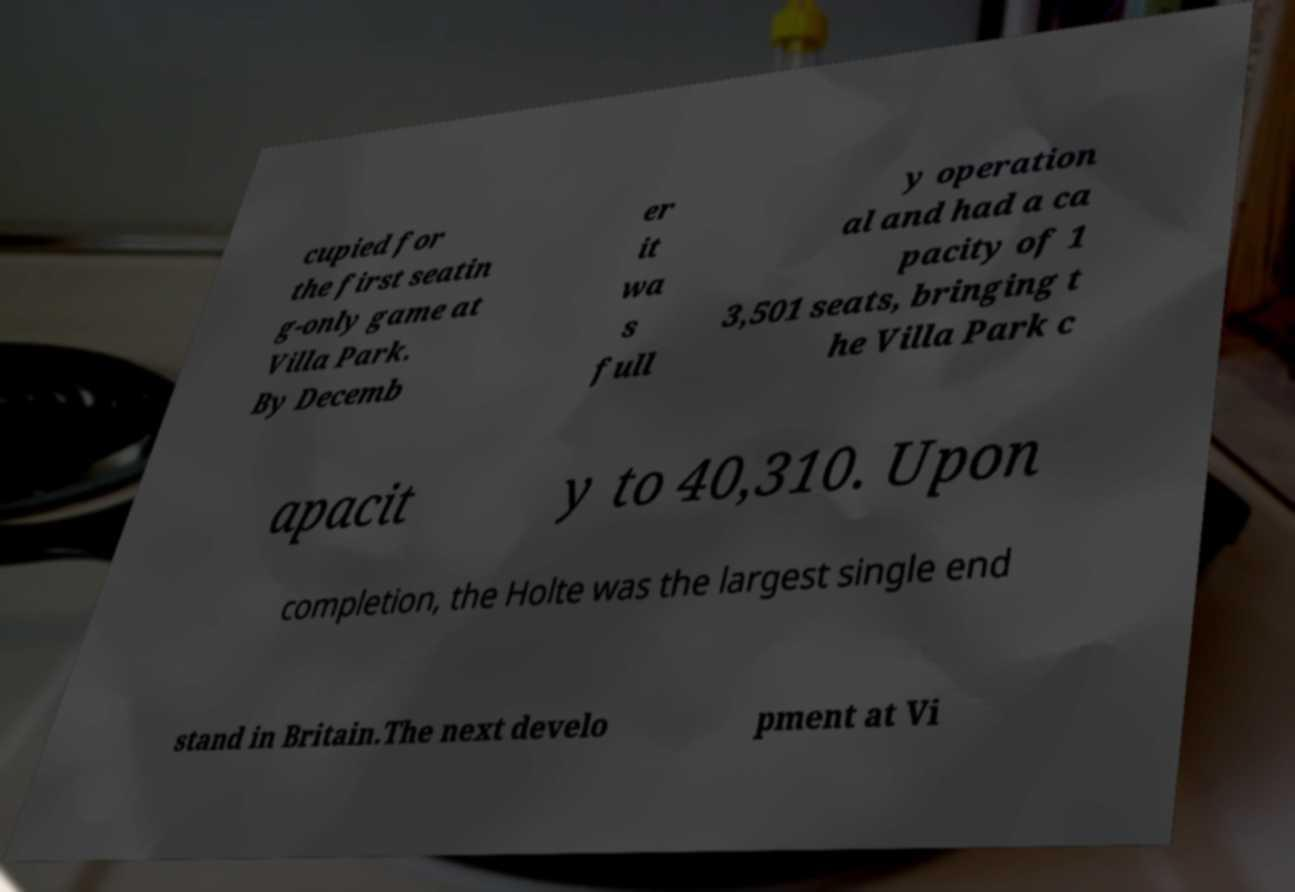What messages or text are displayed in this image? I need them in a readable, typed format. cupied for the first seatin g-only game at Villa Park. By Decemb er it wa s full y operation al and had a ca pacity of 1 3,501 seats, bringing t he Villa Park c apacit y to 40,310. Upon completion, the Holte was the largest single end stand in Britain.The next develo pment at Vi 